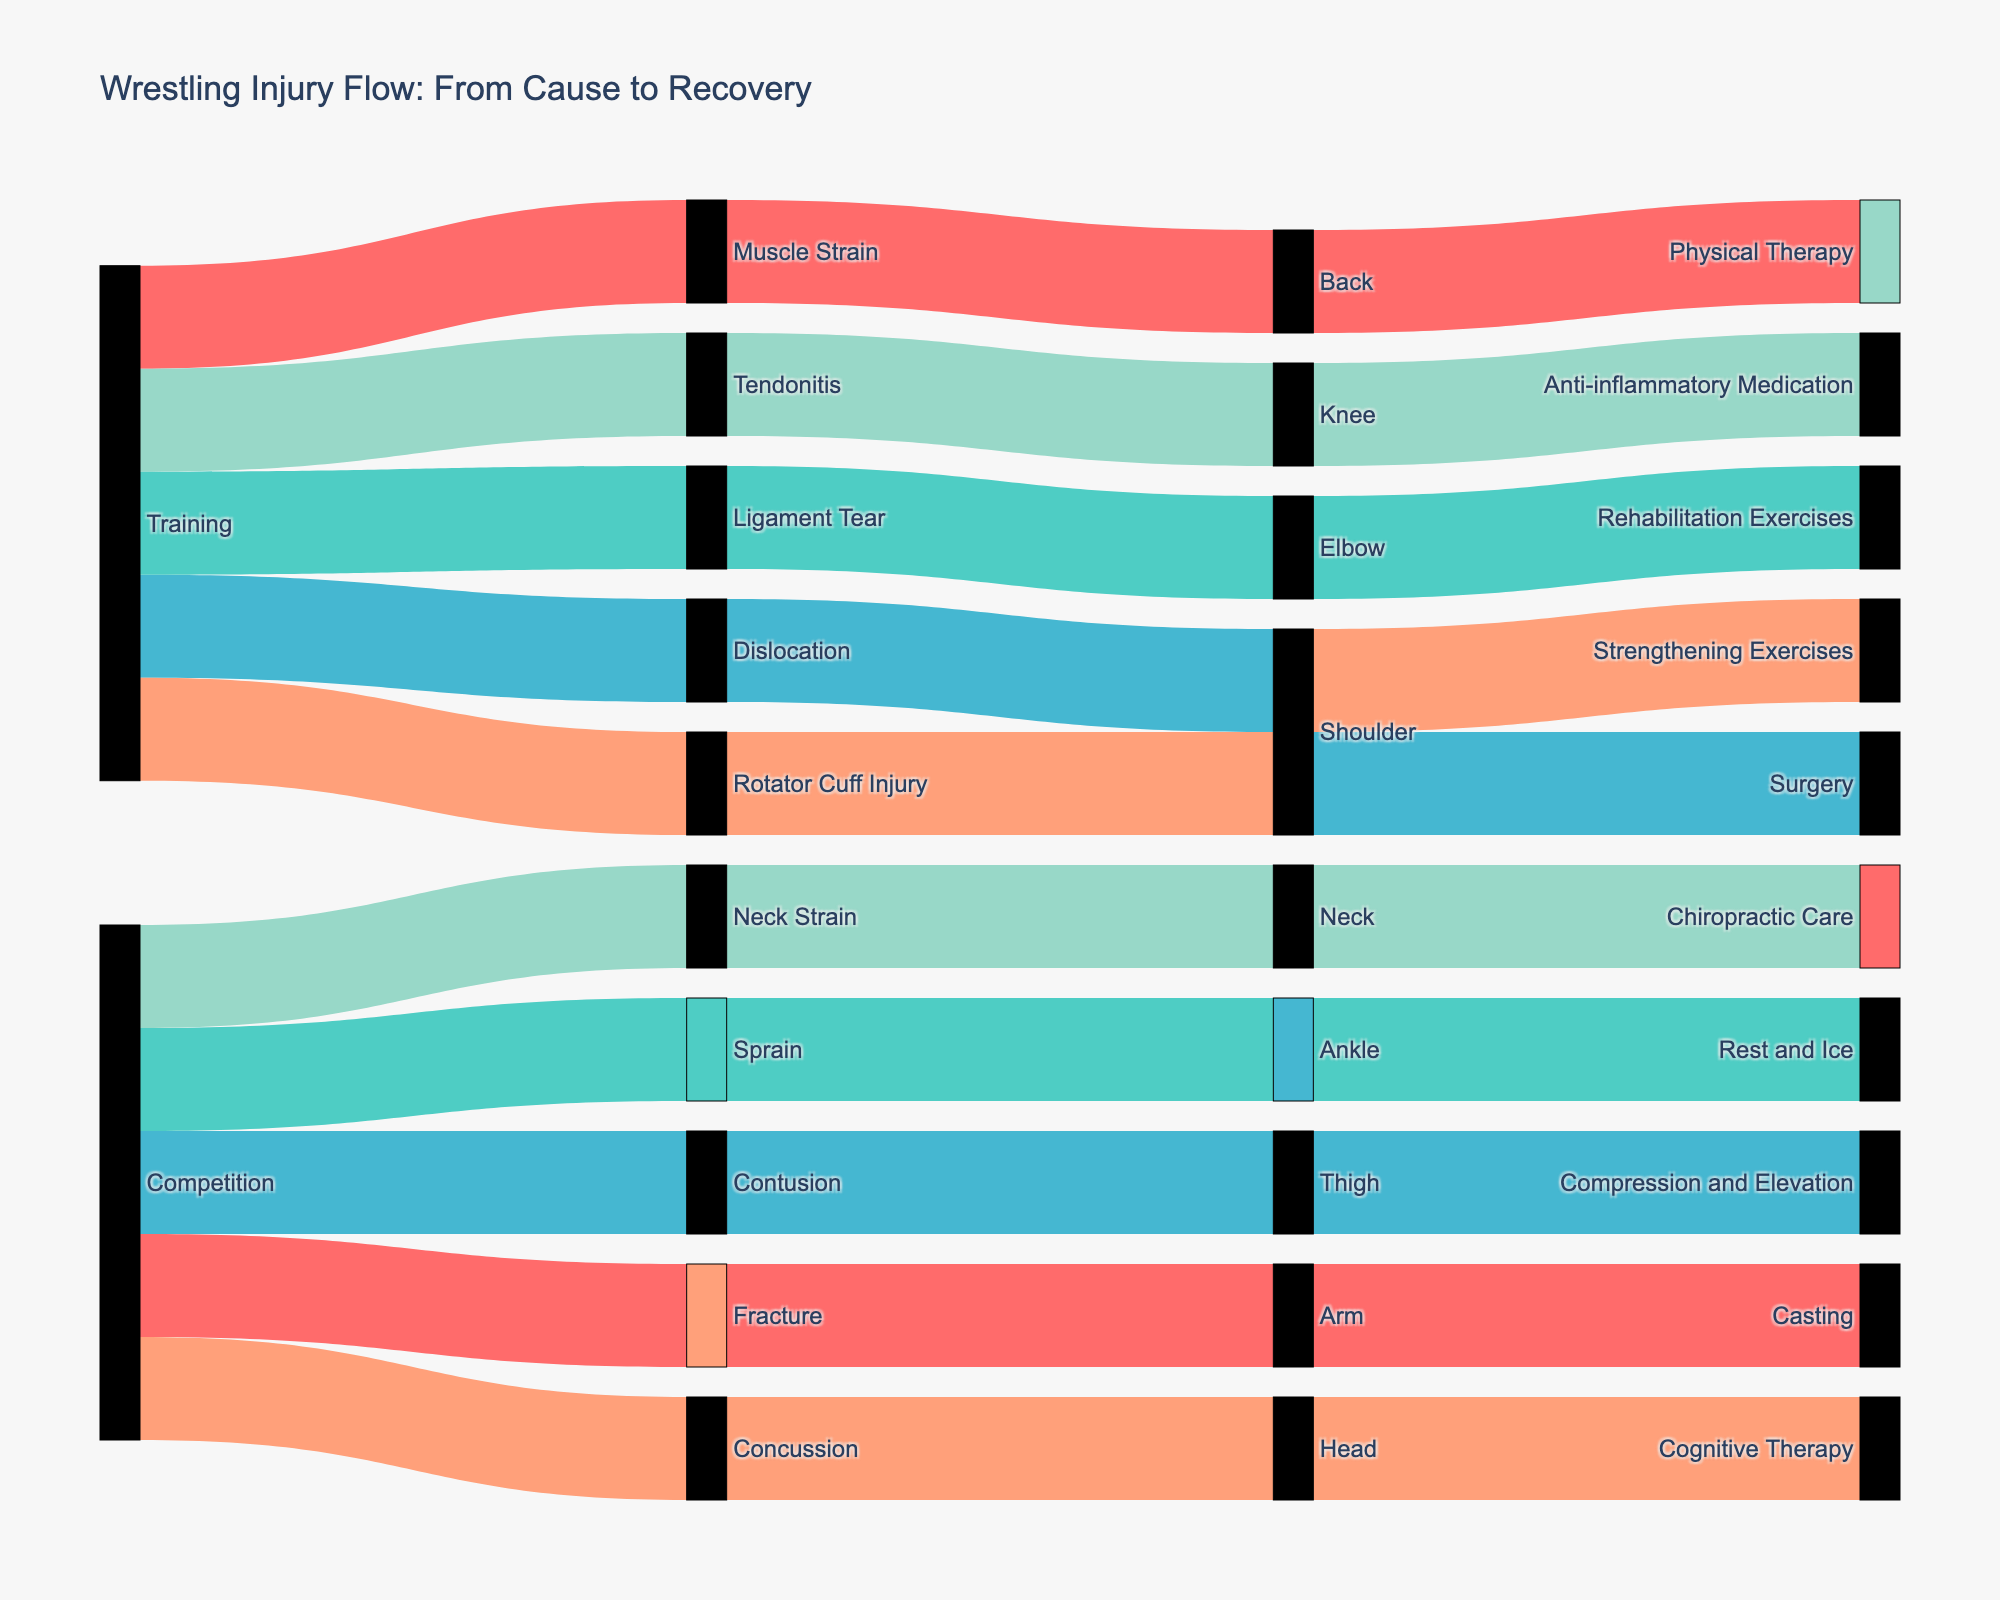How many injuries are caused by training? To determine this, look at the connections starting from "Training" that lead to different injuries. Count the number of unique injuries linked to "Training".
Answer: 5 Which body part is most frequently affected in competition injuries? Trace the connections from "Competition" to each injury, then from each injury to the body part. Identify the body part with the most connections stemming from competition-related injuries.
Answer: Arm What is the most common recovery method for shoulder injuries? Follow the connections from shoulder injuries (injuries that connect to the Shoulder body part) to recovery methods. Identify the most frequently connected recovery method for these shoulder injuries.
Answer: Strengthening Exercises Which source, training or competition, leads to more sprains? Identify the connections leading to sprains from the sources (Training or Competition). Compare the number of connections for each source.
Answer: Competition Are there any injuries that share the same recovery method? If so, which ones? Observe the connections from each injury to their respective recovery methods. If multiple injuries connect to the same recovery method, they share that method. Identify these injuries.
Answer: Yes, Sprain and Contusion both use "Rest and Ice" and "Compression and Elevation" respectively How do the recovery methods for head injuries and neck injuries differ? Follow the connections from the injuries labeled "Head" and "Neck" to their recovery methods. Compare the methods used for these two injuries.
Answer: Head: Cognitive Therapy, Neck: Chiropractic Care What proportion of knee injuries come from training? Identify the connections leading to knee injuries from the sources. Determine the number of connections from the training category and calculate the proportion relative to the total knee injuries.
Answer: All knee injuries come from training Which body part has the least variety in recovery methods? Count the different recovery methods connected to each body part. The body part with the smallest number of unique recovery methods has the least variety.
Answer: Arm What is the total number of recovery methods used for elbow injuries? Identify all the connections leading from elbow injuries to recovery methods. Count the distinct recovery methods connected to elbow injuries.
Answer: 1 Which injury type appears equally in both training and competition sources? Look for injury types that have equal numbers of connections coming from both training and competition sources. Identify those injury types.
Answer: None 